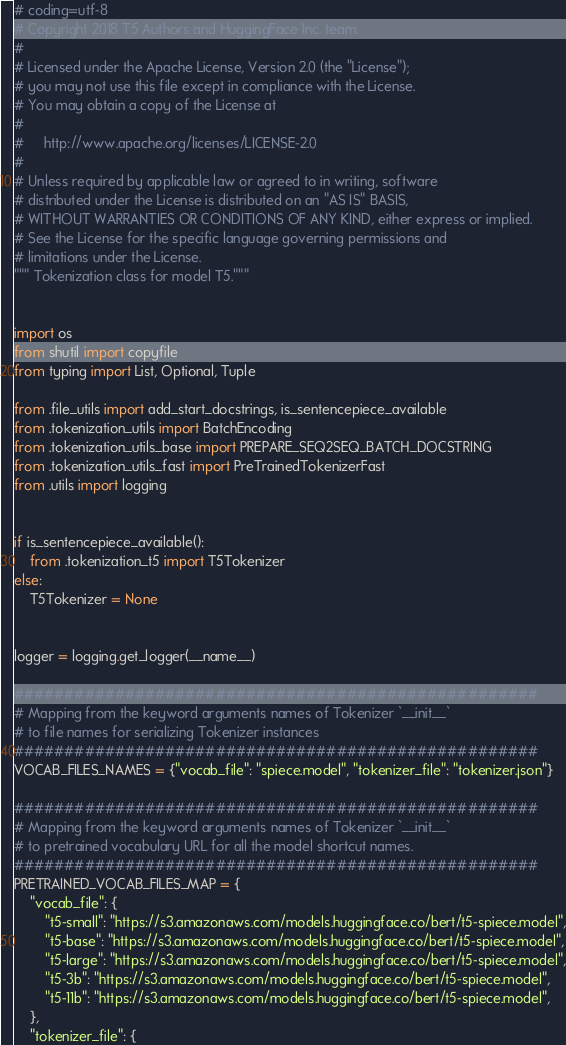Convert code to text. <code><loc_0><loc_0><loc_500><loc_500><_Python_># coding=utf-8
# Copyright 2018 T5 Authors and HuggingFace Inc. team.
#
# Licensed under the Apache License, Version 2.0 (the "License");
# you may not use this file except in compliance with the License.
# You may obtain a copy of the License at
#
#     http://www.apache.org/licenses/LICENSE-2.0
#
# Unless required by applicable law or agreed to in writing, software
# distributed under the License is distributed on an "AS IS" BASIS,
# WITHOUT WARRANTIES OR CONDITIONS OF ANY KIND, either express or implied.
# See the License for the specific language governing permissions and
# limitations under the License.
""" Tokenization class for model T5."""


import os
from shutil import copyfile
from typing import List, Optional, Tuple

from .file_utils import add_start_docstrings, is_sentencepiece_available
from .tokenization_utils import BatchEncoding
from .tokenization_utils_base import PREPARE_SEQ2SEQ_BATCH_DOCSTRING
from .tokenization_utils_fast import PreTrainedTokenizerFast
from .utils import logging


if is_sentencepiece_available():
    from .tokenization_t5 import T5Tokenizer
else:
    T5Tokenizer = None


logger = logging.get_logger(__name__)

####################################################
# Mapping from the keyword arguments names of Tokenizer `__init__`
# to file names for serializing Tokenizer instances
####################################################
VOCAB_FILES_NAMES = {"vocab_file": "spiece.model", "tokenizer_file": "tokenizer.json"}

####################################################
# Mapping from the keyword arguments names of Tokenizer `__init__`
# to pretrained vocabulary URL for all the model shortcut names.
####################################################
PRETRAINED_VOCAB_FILES_MAP = {
    "vocab_file": {
        "t5-small": "https://s3.amazonaws.com/models.huggingface.co/bert/t5-spiece.model",
        "t5-base": "https://s3.amazonaws.com/models.huggingface.co/bert/t5-spiece.model",
        "t5-large": "https://s3.amazonaws.com/models.huggingface.co/bert/t5-spiece.model",
        "t5-3b": "https://s3.amazonaws.com/models.huggingface.co/bert/t5-spiece.model",
        "t5-11b": "https://s3.amazonaws.com/models.huggingface.co/bert/t5-spiece.model",
    },
    "tokenizer_file": {</code> 